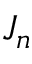Convert formula to latex. <formula><loc_0><loc_0><loc_500><loc_500>J _ { n }</formula> 